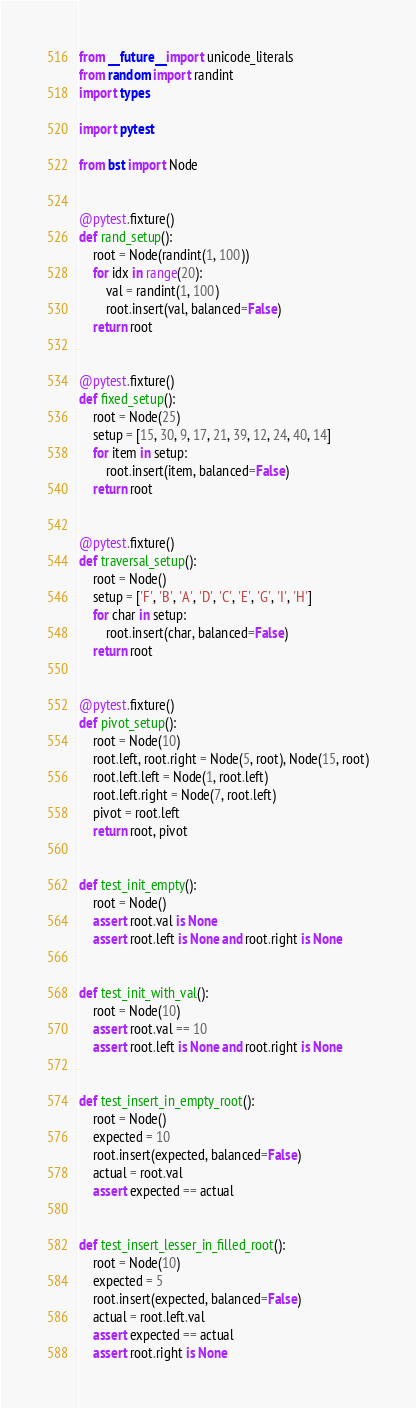<code> <loc_0><loc_0><loc_500><loc_500><_Python_>from __future__ import unicode_literals
from random import randint
import types

import pytest

from bst import Node


@pytest.fixture()
def rand_setup():
    root = Node(randint(1, 100))
    for idx in range(20):
        val = randint(1, 100)
        root.insert(val, balanced=False)
    return root


@pytest.fixture()
def fixed_setup():
    root = Node(25)
    setup = [15, 30, 9, 17, 21, 39, 12, 24, 40, 14]
    for item in setup:
        root.insert(item, balanced=False)
    return root


@pytest.fixture()
def traversal_setup():
    root = Node()
    setup = ['F', 'B', 'A', 'D', 'C', 'E', 'G', 'I', 'H']
    for char in setup:
        root.insert(char, balanced=False)
    return root


@pytest.fixture()
def pivot_setup():
    root = Node(10)
    root.left, root.right = Node(5, root), Node(15, root)
    root.left.left = Node(1, root.left)
    root.left.right = Node(7, root.left)
    pivot = root.left
    return root, pivot


def test_init_empty():
    root = Node()
    assert root.val is None
    assert root.left is None and root.right is None


def test_init_with_val():
    root = Node(10)
    assert root.val == 10
    assert root.left is None and root.right is None


def test_insert_in_empty_root():
    root = Node()
    expected = 10
    root.insert(expected, balanced=False)
    actual = root.val
    assert expected == actual


def test_insert_lesser_in_filled_root():
    root = Node(10)
    expected = 5
    root.insert(expected, balanced=False)
    actual = root.left.val
    assert expected == actual
    assert root.right is None

</code> 